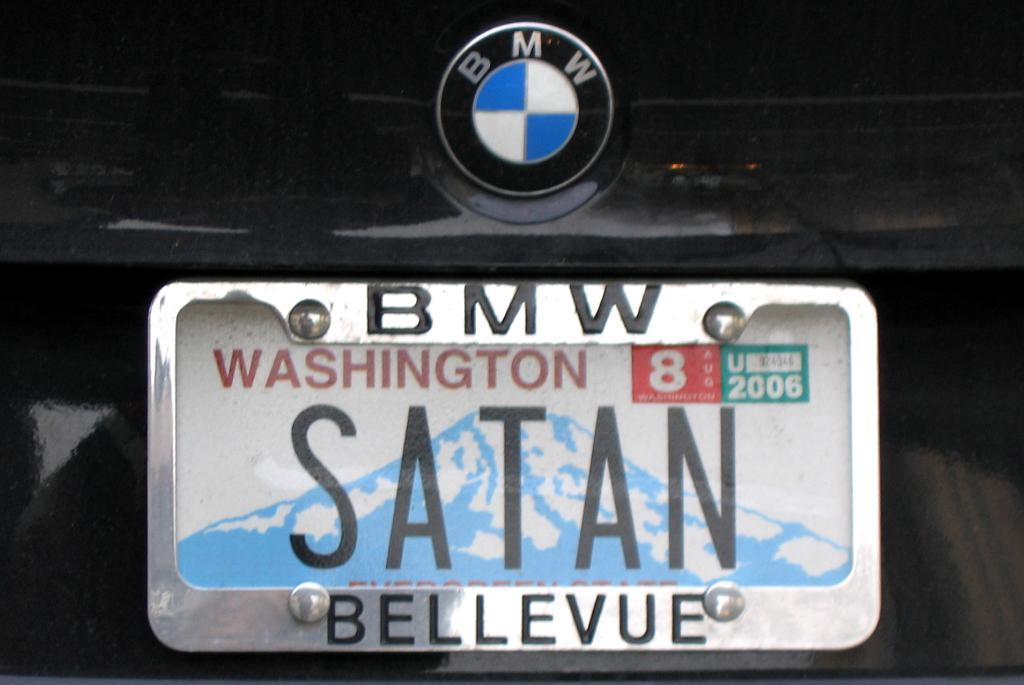Provide a one-sentence caption for the provided image. A BMW license plate with the plate number SATAN from Washington. 